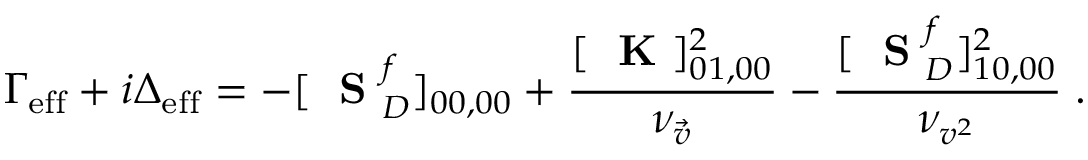<formula> <loc_0><loc_0><loc_500><loc_500>\Gamma _ { e f f } + i \Delta _ { e f f } = - [ S _ { D } ^ { f } ] _ { 0 0 , 0 0 } + \frac { [ K ] _ { 0 1 , 0 0 } ^ { 2 } } { \nu _ { \vec { v } } } - \frac { [ S _ { D } ^ { f } ] _ { 1 0 , 0 0 } ^ { 2 } } { \nu _ { v ^ { 2 } } } \, .</formula> 